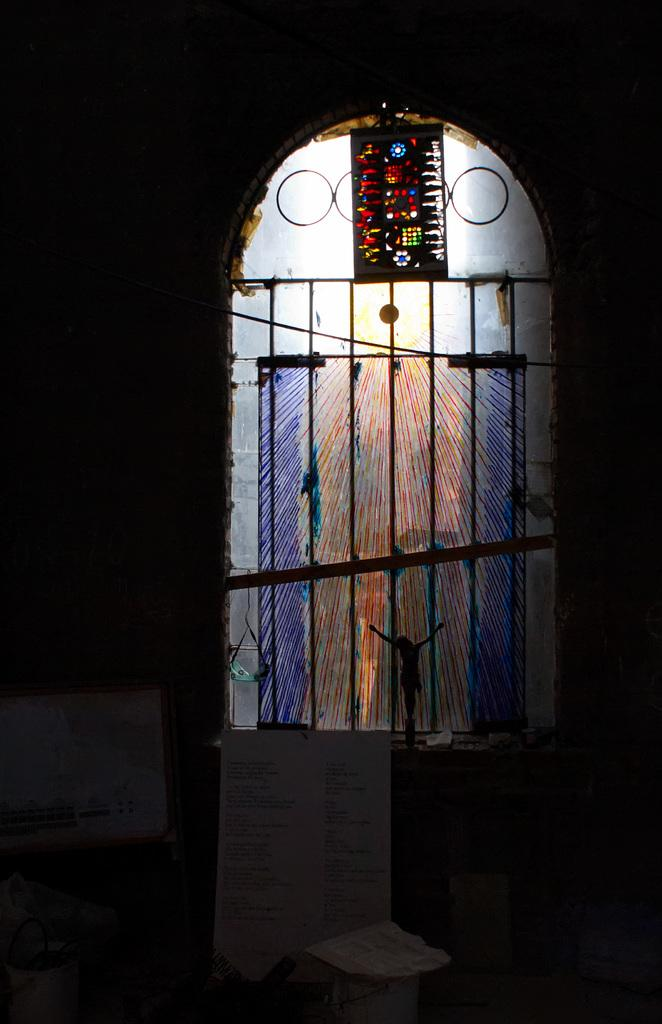What is the main structure in the image? There is a frame in the image. What is attached to the frame? There is a board in the image. What type of object can be seen on the board? There is a toy in the image. Can you describe any other objects present in the image? There are other objects in the image. What can be seen in the background of the image? There is a window with iron grilles in the background of the image. What type of scent can be detected in the image? There is no mention of any scent in the image, so it cannot be determined from the image. 